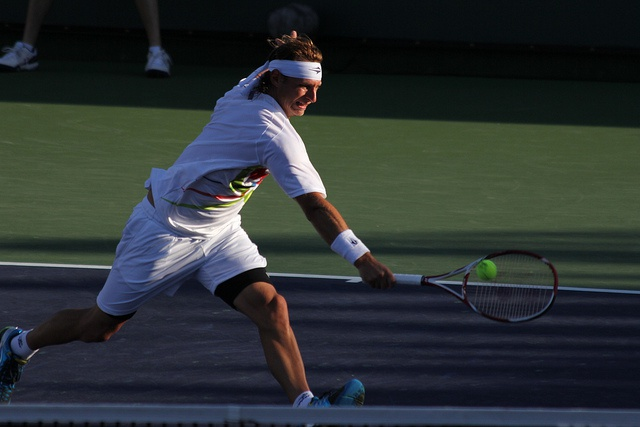Describe the objects in this image and their specific colors. I can see people in black, blue, lightgray, and darkblue tones, tennis racket in black, darkgreen, gray, and blue tones, people in black, navy, darkblue, and blue tones, and sports ball in black, darkgreen, and green tones in this image. 